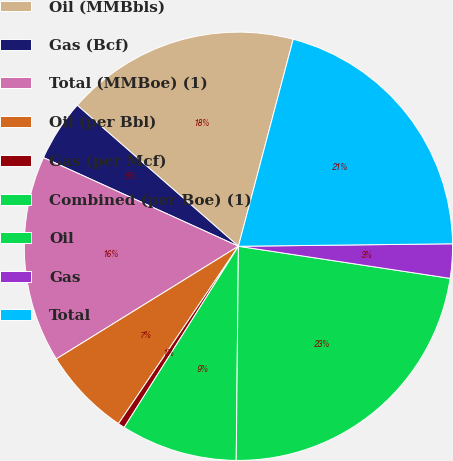Convert chart to OTSL. <chart><loc_0><loc_0><loc_500><loc_500><pie_chart><fcel>Oil (MMBbls)<fcel>Gas (Bcf)<fcel>Total (MMBoe) (1)<fcel>Oil (per Bbl)<fcel>Gas (per Mcf)<fcel>Combined (per Boe) (1)<fcel>Oil<fcel>Gas<fcel>Total<nl><fcel>17.68%<fcel>4.65%<fcel>15.61%<fcel>6.72%<fcel>0.51%<fcel>8.79%<fcel>22.77%<fcel>2.58%<fcel>20.7%<nl></chart> 